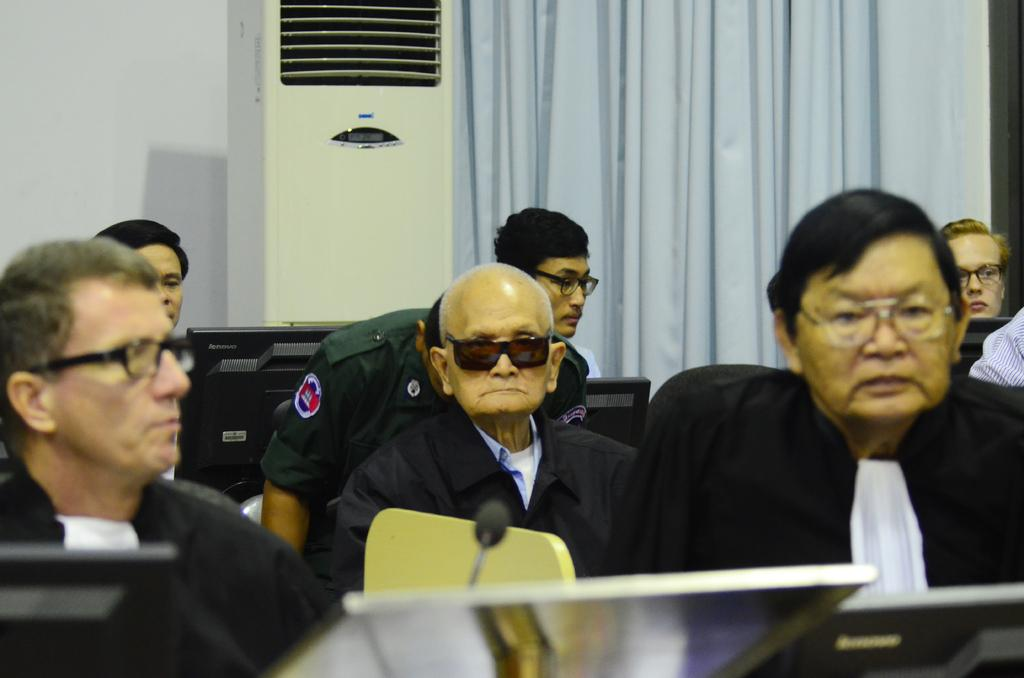What are the men in the foreground of the image doing? The men are sitting on chairs in the foreground of the image. What objects are in front of the men? The men are in front of laptops and monitors. What can be seen in the background of the image? There is a woman's face visible in the background of the image, along with a curtain, an air conditioning unit (AC), and a wall. What type of jelly is being served at the feast in the image? There is no feast or jelly present in the image. How many pickles can be seen on the table in the image? There are no pickles visible in the image. 